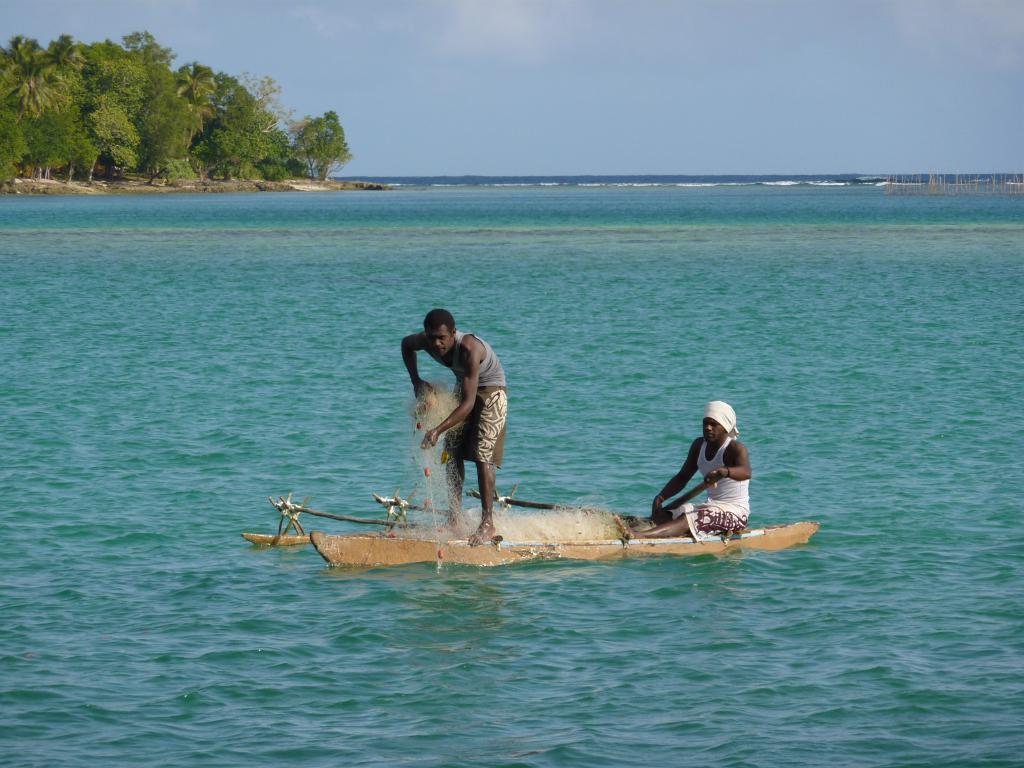How many people are in the boat in the image? There are 2 people in a boat in the image. What is one of the people doing in the image? One person is holding a net in the image. What can be seen in the background of the image? There are trees on the left side of the image and the sky is visible at the top of the image. What is the primary setting of the image? The primary setting of the image is water, as the people are in a boat. What type of wound can be seen on the chin of the person in the boat? There is no wound visible on the chin of the person in the boat, as the image does not show any injuries or wounds. 